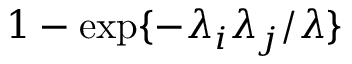Convert formula to latex. <formula><loc_0><loc_0><loc_500><loc_500>1 - \exp \{ - \lambda _ { i } \lambda _ { j } / \lambda \}</formula> 